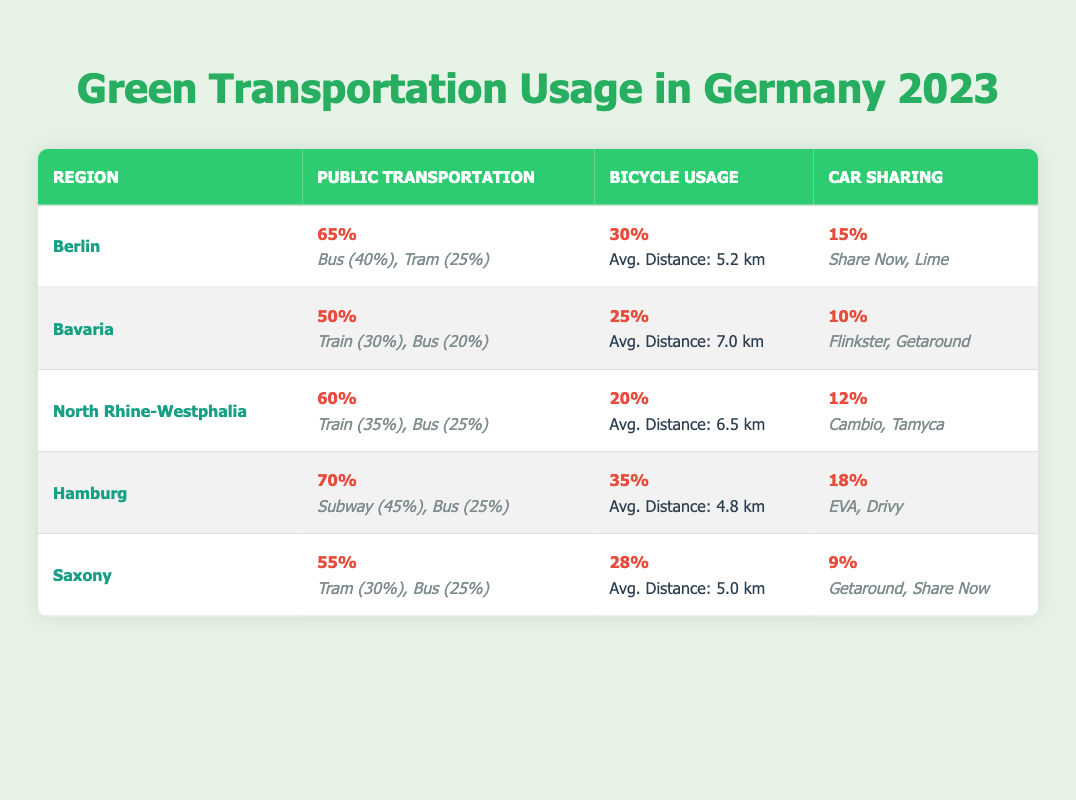What region has the highest public transportation usage percentage? Looking at the table, Hamburg has the highest public transportation usage at 70%.
Answer: Hamburg What is the average distance traveled by bicycle users in Bavaria? The table states that the average distance traveled by bicycle users in Bavaria is 7.0 km.
Answer: 7.0 km Which region has the lowest car-sharing usage percentage? According to the table, Saxony has the lowest car-sharing usage percentage at 9%.
Answer: Saxony What are the popular car-sharing services in Berlin? The table lists "Share Now" and "Lime" as the popular car-sharing services in Berlin.
Answer: Share Now, Lime Is the public transportation usage percentage in North Rhine-Westphalia greater than that in Bavaria? Yes, North Rhine-Westphalia has a 60% public transportation usage compared to Bavaria's 50%.
Answer: Yes How many percentage points more bicycle usage is there in Hamburg compared to North Rhine-Westphalia? Hamburg has 35% bicycle usage while North Rhine-Westphalia has 20%, so the difference is 35% - 20% = 15%.
Answer: 15 percentage points What is the total percentage of public transportation usage for all regions listed? The percentages for public transportation usage are 65 + 50 + 60 + 70 + 55 = 300. Thus, the total percentage is 300%.
Answer: 300% Which mode of public transportation is most used in Hamburg? The table indicates that the subway is the most used mode of public transportation in Hamburg at 45%.
Answer: Subway In which region is bicycle usage greater than 30%? According to the table, both Hamburg (35%) and Berlin (30%) have bicycle usage percentages that are equal to or greater than 30%.
Answer: Hamburg, Berlin What is the average percentage of car-sharing usage across all regions? Adding all car-sharing usage percentages: 15 + 10 + 12 + 18 + 9 = 64, dividing by 5 regions gives an average of 64 / 5 = 12.8%.
Answer: 12.8% 